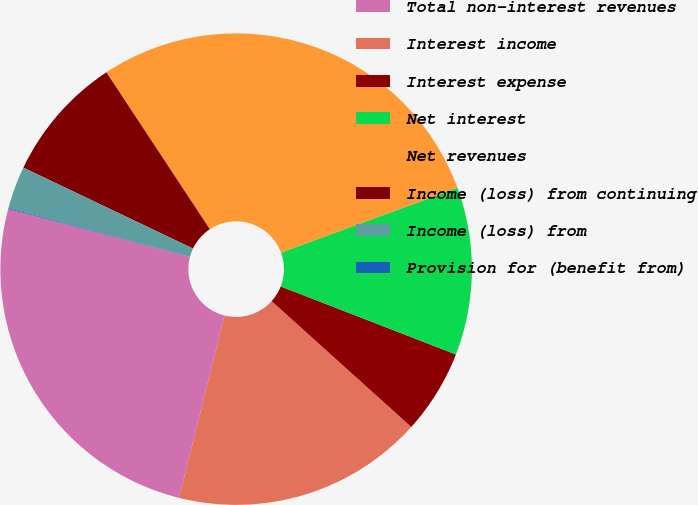Convert chart to OTSL. <chart><loc_0><loc_0><loc_500><loc_500><pie_chart><fcel>Total non-interest revenues<fcel>Interest income<fcel>Interest expense<fcel>Net interest<fcel>Net revenues<fcel>Income (loss) from continuing<fcel>Income (loss) from<fcel>Provision for (benefit from)<nl><fcel>25.21%<fcel>17.22%<fcel>5.78%<fcel>11.5%<fcel>28.67%<fcel>8.64%<fcel>2.92%<fcel>0.06%<nl></chart> 